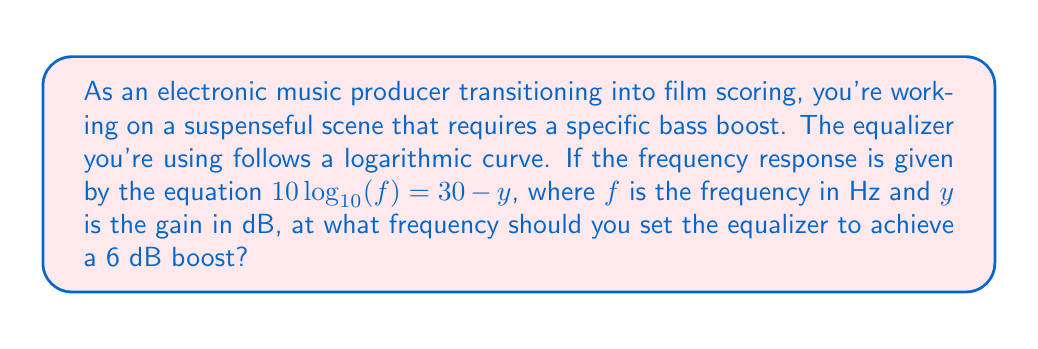Teach me how to tackle this problem. Let's solve this step-by-step:

1) We're given the equation: $10\log_{10}(f) = 30 - y$

2) We want to find $f$ when $y = 6$ (since we want a 6 dB boost)

3) Substitute $y = 6$ into the equation:
   $10\log_{10}(f) = 30 - 6$
   $10\log_{10}(f) = 24$

4) Divide both sides by 10:
   $\log_{10}(f) = 2.4$

5) To solve for $f$, we need to apply the inverse function (exponential) to both sides:
   $10^{\log_{10}(f)} = 10^{2.4}$

6) The left side simplifies to $f$:
   $f = 10^{2.4}$

7) Calculate the value:
   $f \approx 251.19$ Hz

Therefore, you should set the equalizer to approximately 251 Hz to achieve a 6 dB boost.
Answer: 251 Hz 